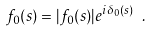<formula> <loc_0><loc_0><loc_500><loc_500>f _ { 0 } ( s ) = | f _ { 0 } ( s ) | e ^ { i \delta _ { 0 } ( s ) } \ .</formula> 